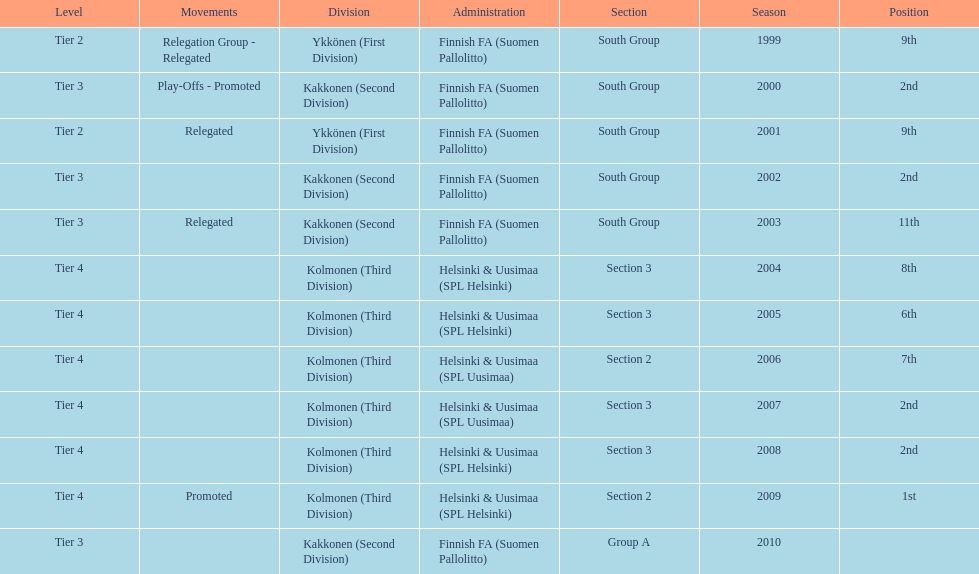Which administration has the least amount of division? Helsinki & Uusimaa (SPL Helsinki). 